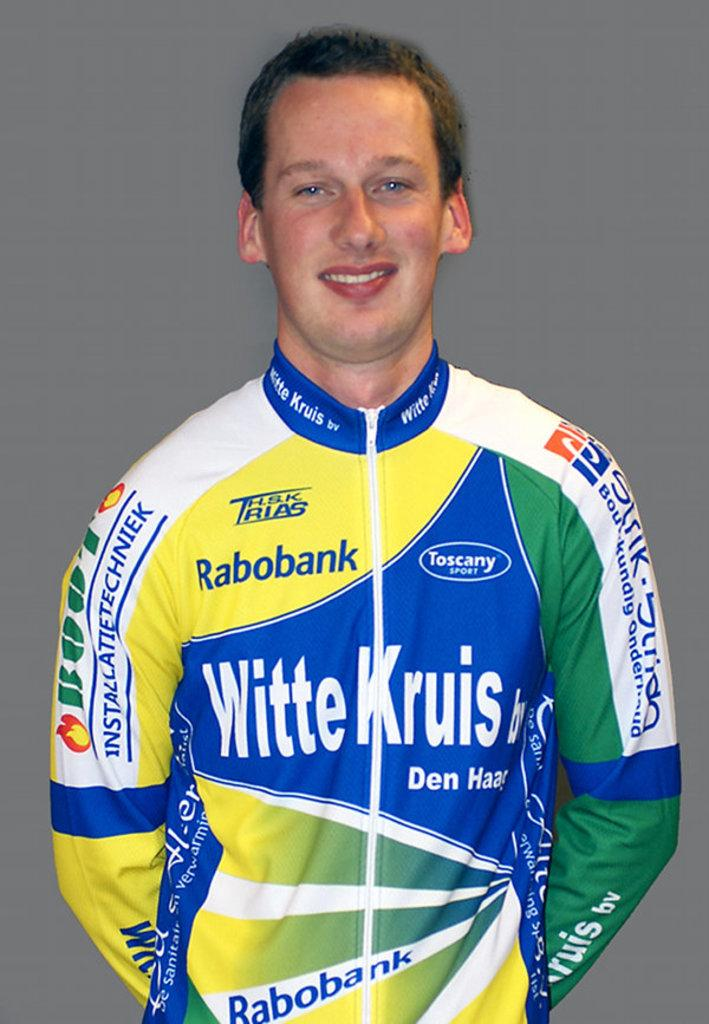What is the main subject of the picture? The main subject of the picture is a sports player. What is the sports player doing in the picture? The sports player is posing for a photograph. What can be seen on the sports player's shirt? There are names of different sponsor companies on the player's shirt. Can you tell me how many pigs are visible in the picture? There are no pigs visible in the picture; it features a sports player posing for a photograph. What type of industry is the sports player working in, as seen in the picture? The picture does not provide information about the sports player's industry; it only shows the player posing for a photograph with sponsor company names on their shirt. 